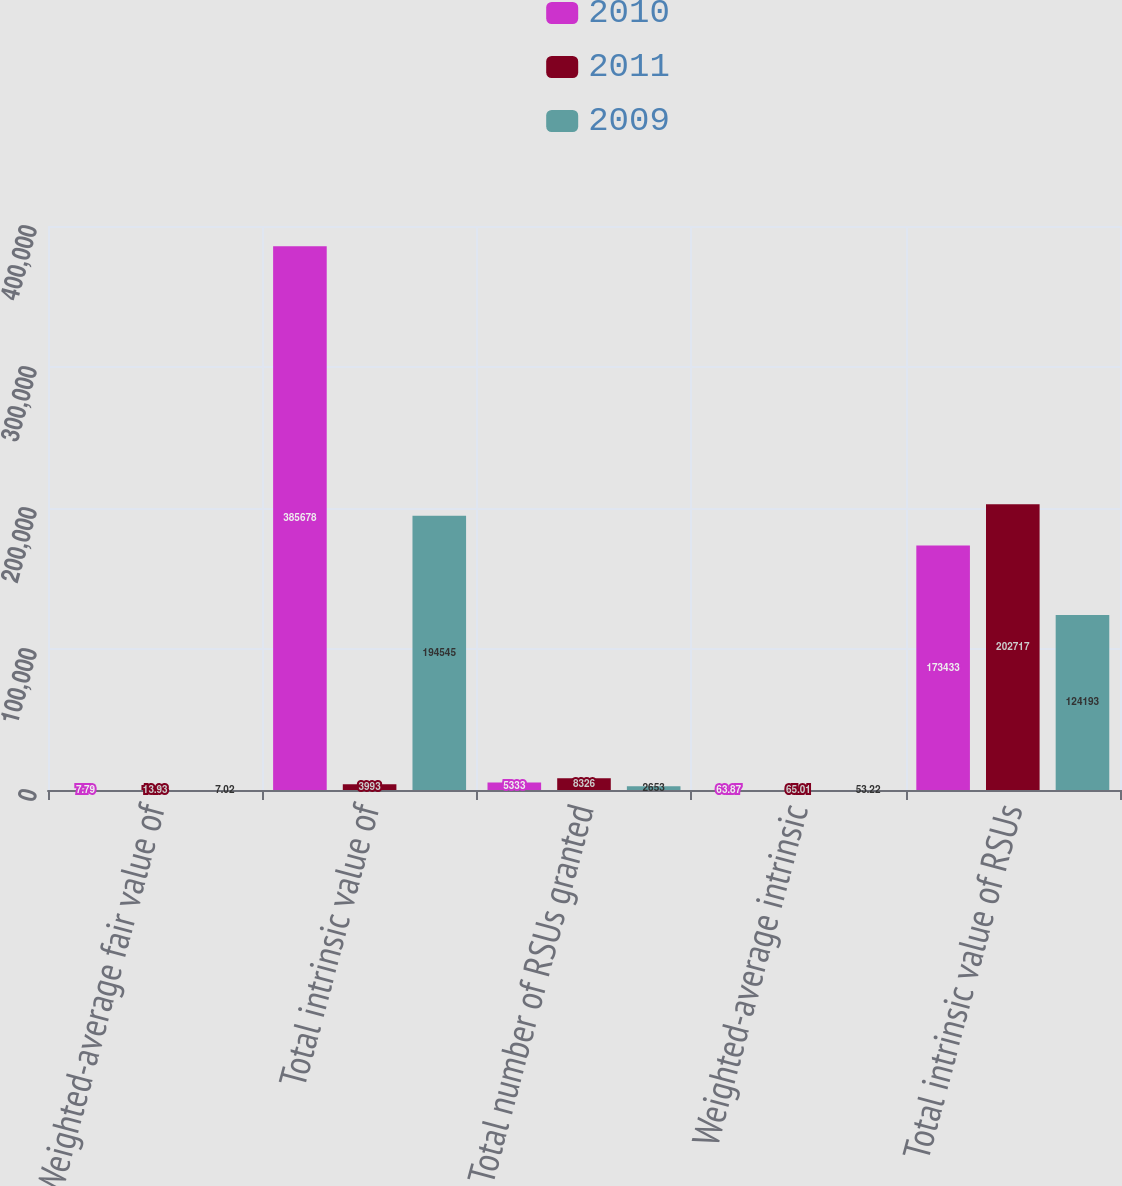Convert chart. <chart><loc_0><loc_0><loc_500><loc_500><stacked_bar_chart><ecel><fcel>Weighted-average fair value of<fcel>Total intrinsic value of<fcel>Total number of RSUs granted<fcel>Weighted-average intrinsic<fcel>Total intrinsic value of RSUs<nl><fcel>2010<fcel>7.79<fcel>385678<fcel>5333<fcel>63.87<fcel>173433<nl><fcel>2011<fcel>13.93<fcel>3993<fcel>8326<fcel>65.01<fcel>202717<nl><fcel>2009<fcel>7.02<fcel>194545<fcel>2653<fcel>53.22<fcel>124193<nl></chart> 